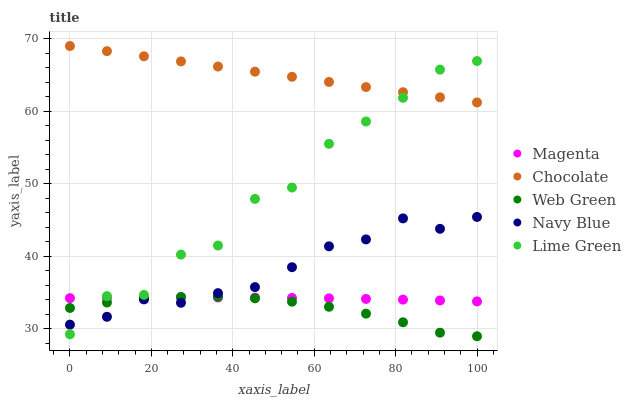Does Web Green have the minimum area under the curve?
Answer yes or no. Yes. Does Chocolate have the maximum area under the curve?
Answer yes or no. Yes. Does Magenta have the minimum area under the curve?
Answer yes or no. No. Does Magenta have the maximum area under the curve?
Answer yes or no. No. Is Chocolate the smoothest?
Answer yes or no. Yes. Is Lime Green the roughest?
Answer yes or no. Yes. Is Magenta the smoothest?
Answer yes or no. No. Is Magenta the roughest?
Answer yes or no. No. Does Web Green have the lowest value?
Answer yes or no. Yes. Does Magenta have the lowest value?
Answer yes or no. No. Does Chocolate have the highest value?
Answer yes or no. Yes. Does Lime Green have the highest value?
Answer yes or no. No. Is Web Green less than Chocolate?
Answer yes or no. Yes. Is Chocolate greater than Web Green?
Answer yes or no. Yes. Does Lime Green intersect Web Green?
Answer yes or no. Yes. Is Lime Green less than Web Green?
Answer yes or no. No. Is Lime Green greater than Web Green?
Answer yes or no. No. Does Web Green intersect Chocolate?
Answer yes or no. No. 